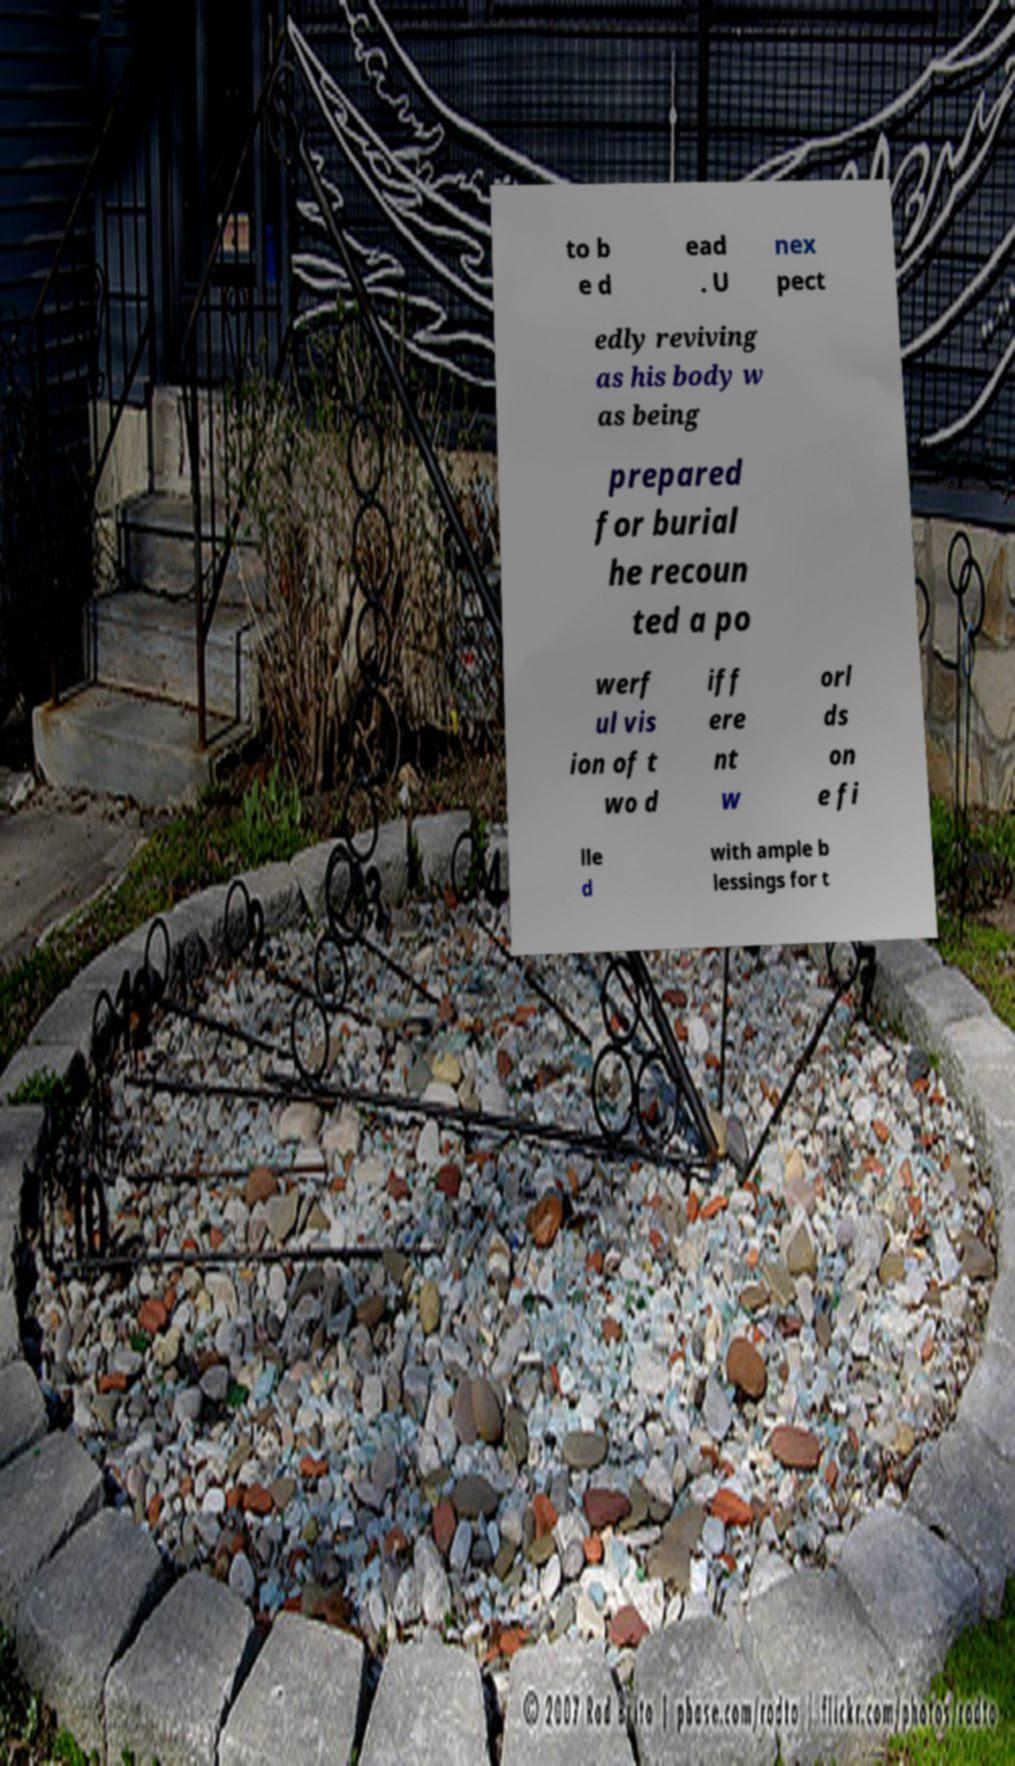Could you assist in decoding the text presented in this image and type it out clearly? to b e d ead . U nex pect edly reviving as his body w as being prepared for burial he recoun ted a po werf ul vis ion of t wo d iff ere nt w orl ds on e fi lle d with ample b lessings for t 